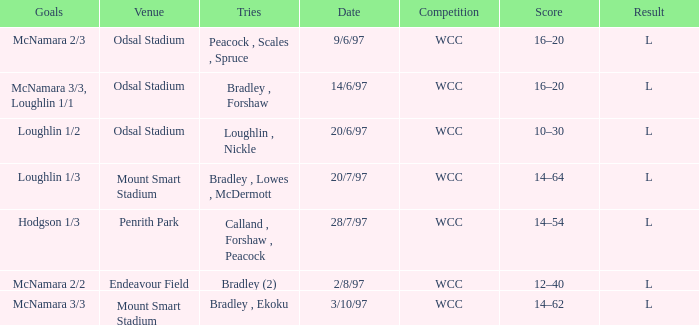What were the goals on 3/10/97? McNamara 3/3. 